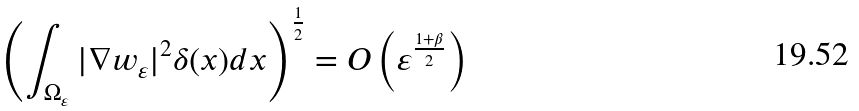Convert formula to latex. <formula><loc_0><loc_0><loc_500><loc_500>\left ( \int _ { \Omega _ { \varepsilon } } | \nabla w _ { \varepsilon } | ^ { 2 } \delta ( x ) d x \right ) ^ { \frac { 1 } { 2 } } = O \left ( \varepsilon ^ { \frac { 1 + \beta } { 2 } } \right )</formula> 